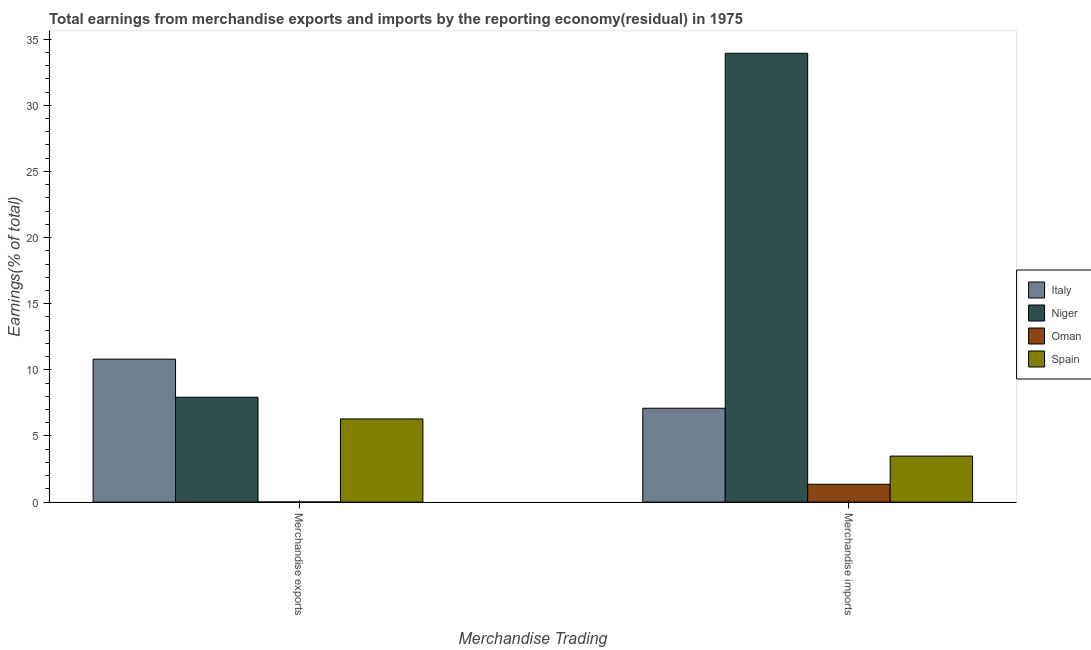How many groups of bars are there?
Your response must be concise. 2. Are the number of bars per tick equal to the number of legend labels?
Provide a short and direct response. Yes. Are the number of bars on each tick of the X-axis equal?
Your answer should be very brief. Yes. What is the earnings from merchandise imports in Spain?
Make the answer very short. 3.48. Across all countries, what is the maximum earnings from merchandise exports?
Offer a terse response. 10.81. Across all countries, what is the minimum earnings from merchandise exports?
Give a very brief answer. 0.01. In which country was the earnings from merchandise exports maximum?
Give a very brief answer. Italy. In which country was the earnings from merchandise exports minimum?
Ensure brevity in your answer.  Oman. What is the total earnings from merchandise exports in the graph?
Your answer should be very brief. 25.05. What is the difference between the earnings from merchandise imports in Niger and that in Italy?
Your response must be concise. 26.84. What is the difference between the earnings from merchandise exports in Italy and the earnings from merchandise imports in Spain?
Your response must be concise. 7.33. What is the average earnings from merchandise imports per country?
Your response must be concise. 11.47. What is the difference between the earnings from merchandise exports and earnings from merchandise imports in Oman?
Offer a terse response. -1.34. What is the ratio of the earnings from merchandise exports in Italy to that in Spain?
Your answer should be compact. 1.72. What does the 3rd bar from the left in Merchandise exports represents?
Offer a very short reply. Oman. Are all the bars in the graph horizontal?
Provide a succinct answer. No. Does the graph contain any zero values?
Offer a terse response. No. Where does the legend appear in the graph?
Make the answer very short. Center right. How many legend labels are there?
Give a very brief answer. 4. How are the legend labels stacked?
Your answer should be very brief. Vertical. What is the title of the graph?
Your answer should be very brief. Total earnings from merchandise exports and imports by the reporting economy(residual) in 1975. Does "Brunei Darussalam" appear as one of the legend labels in the graph?
Keep it short and to the point. No. What is the label or title of the X-axis?
Keep it short and to the point. Merchandise Trading. What is the label or title of the Y-axis?
Give a very brief answer. Earnings(% of total). What is the Earnings(% of total) in Italy in Merchandise exports?
Provide a short and direct response. 10.81. What is the Earnings(% of total) of Niger in Merchandise exports?
Provide a succinct answer. 7.93. What is the Earnings(% of total) of Oman in Merchandise exports?
Offer a very short reply. 0.01. What is the Earnings(% of total) in Spain in Merchandise exports?
Ensure brevity in your answer.  6.29. What is the Earnings(% of total) of Italy in Merchandise imports?
Offer a terse response. 7.1. What is the Earnings(% of total) of Niger in Merchandise imports?
Provide a short and direct response. 33.94. What is the Earnings(% of total) of Oman in Merchandise imports?
Offer a very short reply. 1.35. What is the Earnings(% of total) in Spain in Merchandise imports?
Provide a succinct answer. 3.48. Across all Merchandise Trading, what is the maximum Earnings(% of total) in Italy?
Your response must be concise. 10.81. Across all Merchandise Trading, what is the maximum Earnings(% of total) of Niger?
Offer a terse response. 33.94. Across all Merchandise Trading, what is the maximum Earnings(% of total) of Oman?
Offer a very short reply. 1.35. Across all Merchandise Trading, what is the maximum Earnings(% of total) of Spain?
Your answer should be very brief. 6.29. Across all Merchandise Trading, what is the minimum Earnings(% of total) in Italy?
Ensure brevity in your answer.  7.1. Across all Merchandise Trading, what is the minimum Earnings(% of total) in Niger?
Your response must be concise. 7.93. Across all Merchandise Trading, what is the minimum Earnings(% of total) in Oman?
Provide a short and direct response. 0.01. Across all Merchandise Trading, what is the minimum Earnings(% of total) in Spain?
Offer a very short reply. 3.48. What is the total Earnings(% of total) in Italy in the graph?
Give a very brief answer. 17.91. What is the total Earnings(% of total) in Niger in the graph?
Ensure brevity in your answer.  41.87. What is the total Earnings(% of total) in Oman in the graph?
Ensure brevity in your answer.  1.37. What is the total Earnings(% of total) in Spain in the graph?
Ensure brevity in your answer.  9.77. What is the difference between the Earnings(% of total) in Italy in Merchandise exports and that in Merchandise imports?
Provide a succinct answer. 3.71. What is the difference between the Earnings(% of total) of Niger in Merchandise exports and that in Merchandise imports?
Ensure brevity in your answer.  -26. What is the difference between the Earnings(% of total) of Oman in Merchandise exports and that in Merchandise imports?
Offer a terse response. -1.34. What is the difference between the Earnings(% of total) in Spain in Merchandise exports and that in Merchandise imports?
Make the answer very short. 2.81. What is the difference between the Earnings(% of total) of Italy in Merchandise exports and the Earnings(% of total) of Niger in Merchandise imports?
Provide a short and direct response. -23.13. What is the difference between the Earnings(% of total) in Italy in Merchandise exports and the Earnings(% of total) in Oman in Merchandise imports?
Provide a short and direct response. 9.46. What is the difference between the Earnings(% of total) of Italy in Merchandise exports and the Earnings(% of total) of Spain in Merchandise imports?
Offer a terse response. 7.33. What is the difference between the Earnings(% of total) of Niger in Merchandise exports and the Earnings(% of total) of Oman in Merchandise imports?
Ensure brevity in your answer.  6.58. What is the difference between the Earnings(% of total) of Niger in Merchandise exports and the Earnings(% of total) of Spain in Merchandise imports?
Offer a terse response. 4.45. What is the difference between the Earnings(% of total) in Oman in Merchandise exports and the Earnings(% of total) in Spain in Merchandise imports?
Offer a very short reply. -3.47. What is the average Earnings(% of total) of Italy per Merchandise Trading?
Provide a short and direct response. 8.95. What is the average Earnings(% of total) in Niger per Merchandise Trading?
Provide a succinct answer. 20.93. What is the average Earnings(% of total) of Oman per Merchandise Trading?
Your answer should be very brief. 0.68. What is the average Earnings(% of total) in Spain per Merchandise Trading?
Keep it short and to the point. 4.89. What is the difference between the Earnings(% of total) in Italy and Earnings(% of total) in Niger in Merchandise exports?
Your response must be concise. 2.88. What is the difference between the Earnings(% of total) of Italy and Earnings(% of total) of Oman in Merchandise exports?
Keep it short and to the point. 10.8. What is the difference between the Earnings(% of total) of Italy and Earnings(% of total) of Spain in Merchandise exports?
Provide a succinct answer. 4.52. What is the difference between the Earnings(% of total) of Niger and Earnings(% of total) of Oman in Merchandise exports?
Your response must be concise. 7.92. What is the difference between the Earnings(% of total) of Niger and Earnings(% of total) of Spain in Merchandise exports?
Your answer should be very brief. 1.64. What is the difference between the Earnings(% of total) of Oman and Earnings(% of total) of Spain in Merchandise exports?
Offer a terse response. -6.28. What is the difference between the Earnings(% of total) in Italy and Earnings(% of total) in Niger in Merchandise imports?
Your answer should be very brief. -26.84. What is the difference between the Earnings(% of total) in Italy and Earnings(% of total) in Oman in Merchandise imports?
Offer a terse response. 5.75. What is the difference between the Earnings(% of total) of Italy and Earnings(% of total) of Spain in Merchandise imports?
Keep it short and to the point. 3.62. What is the difference between the Earnings(% of total) of Niger and Earnings(% of total) of Oman in Merchandise imports?
Provide a short and direct response. 32.58. What is the difference between the Earnings(% of total) of Niger and Earnings(% of total) of Spain in Merchandise imports?
Your response must be concise. 30.45. What is the difference between the Earnings(% of total) of Oman and Earnings(% of total) of Spain in Merchandise imports?
Your response must be concise. -2.13. What is the ratio of the Earnings(% of total) in Italy in Merchandise exports to that in Merchandise imports?
Ensure brevity in your answer.  1.52. What is the ratio of the Earnings(% of total) in Niger in Merchandise exports to that in Merchandise imports?
Your answer should be compact. 0.23. What is the ratio of the Earnings(% of total) of Oman in Merchandise exports to that in Merchandise imports?
Provide a short and direct response. 0.01. What is the ratio of the Earnings(% of total) of Spain in Merchandise exports to that in Merchandise imports?
Offer a very short reply. 1.81. What is the difference between the highest and the second highest Earnings(% of total) of Italy?
Ensure brevity in your answer.  3.71. What is the difference between the highest and the second highest Earnings(% of total) in Niger?
Ensure brevity in your answer.  26. What is the difference between the highest and the second highest Earnings(% of total) in Oman?
Your response must be concise. 1.34. What is the difference between the highest and the second highest Earnings(% of total) of Spain?
Provide a succinct answer. 2.81. What is the difference between the highest and the lowest Earnings(% of total) in Italy?
Offer a terse response. 3.71. What is the difference between the highest and the lowest Earnings(% of total) in Niger?
Provide a succinct answer. 26. What is the difference between the highest and the lowest Earnings(% of total) of Oman?
Provide a succinct answer. 1.34. What is the difference between the highest and the lowest Earnings(% of total) in Spain?
Ensure brevity in your answer.  2.81. 